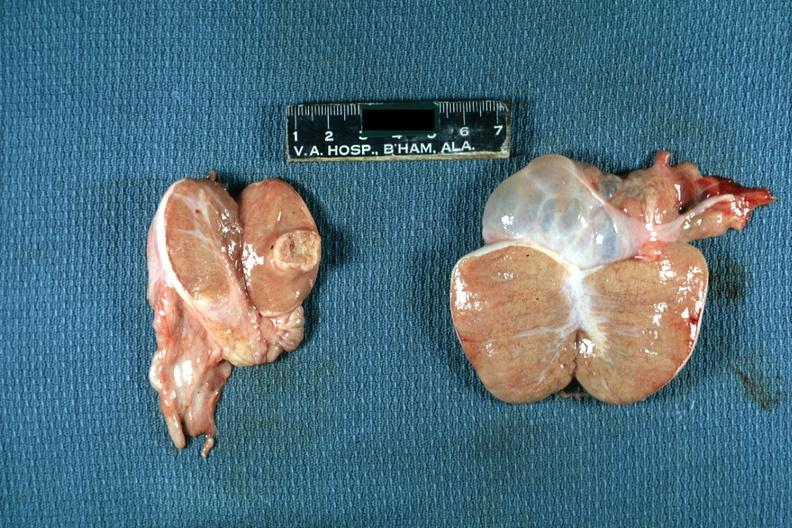s testicle present?
Answer the question using a single word or phrase. Yes 